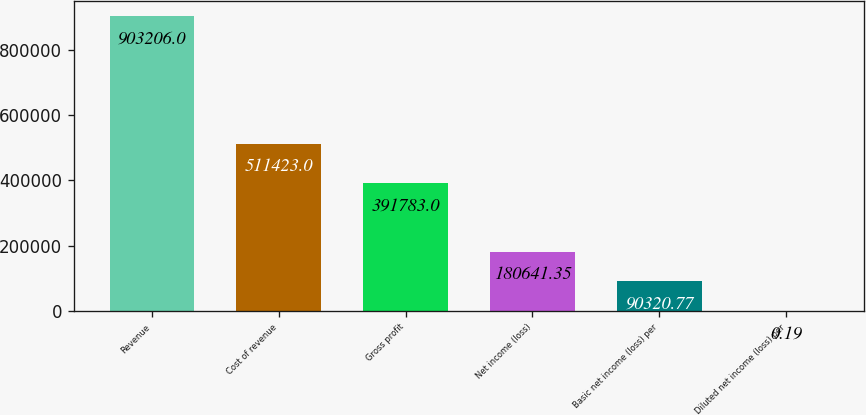<chart> <loc_0><loc_0><loc_500><loc_500><bar_chart><fcel>Revenue<fcel>Cost of revenue<fcel>Gross profit<fcel>Net income (loss)<fcel>Basic net income (loss) per<fcel>Diluted net income (loss) per<nl><fcel>903206<fcel>511423<fcel>391783<fcel>180641<fcel>90320.8<fcel>0.19<nl></chart> 